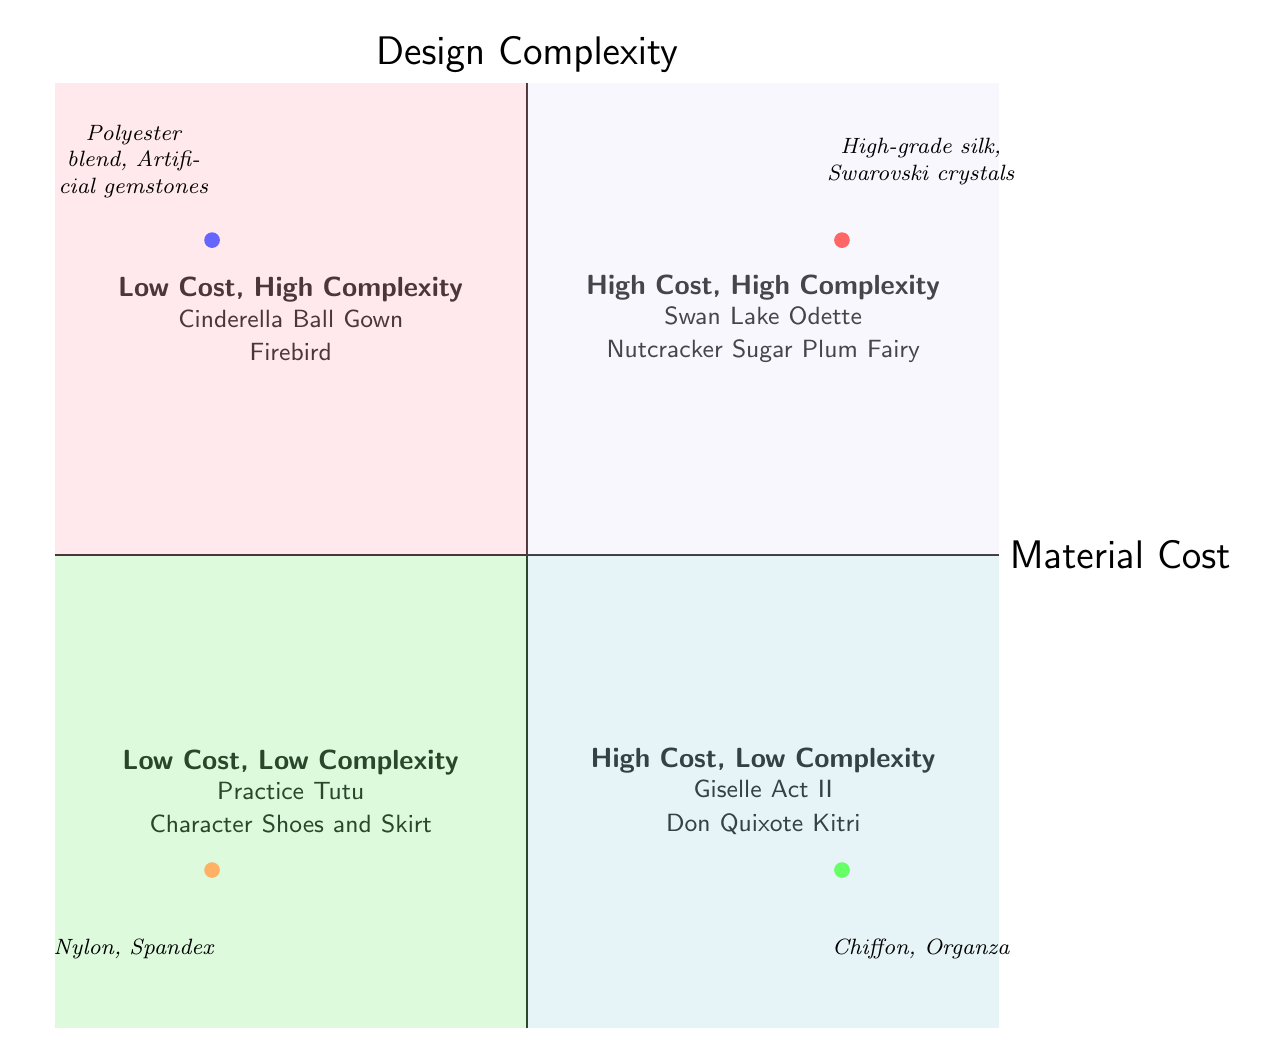What costume types are in the High Material Cost, High Design Complexity quadrant? The quadrant label "High Cost, High Complexity" lists "Swan Lake Odette" and "Nutcracker Sugar Plum Fairy" as the costume types.
Answer: Swan Lake Odette, Nutcracker Sugar Plum Fairy Which costume type contains chiffon as a material? In the "High Cost, Low Complexity" quadrant, the costume type "Giselle Act II" is identified as containing chiffon materials.
Answer: Giselle Act II How many costume types are listed in the Low Material Cost, Low Design Complexity quadrant? The "Low Cost, Low Complexity" quadrant contains two costume types: "Practice Tutu" and "Character Shoes and Skirt," totaling two costume types.
Answer: 2 What is the primary design feature of the "Nutcracker Sugar Plum Fairy"? The design features for "Nutcracker Sugar Plum Fairy" include "Intricate lace patterns" which is the primary one highlighted in the quadrant.
Answer: Intricate lace patterns Which quadrant features costumes made from polyester blend? The "Low Cost, High Complexity" quadrant contains the "Cinderella Ball Gown," which is made from a polyester blend, indicating it is in that quadrant.
Answer: Low Cost, High Complexity What is common among the costumes in the High Material Cost, Low Design Complexity quadrant? All the costumes in this quadrant use high-quality materials such as chiffon and satin, which are indicative of their high material cost.
Answer: High-quality materials What type of materials is used for the character shoes in the Low Cost, Low Complexity quadrant? The materials for "Character Shoes and Skirt" include "Leatherette," identifying the material characteristic for this costume type in the appropriate quadrant.
Answer: Leatherette Which two costume types are listed in the Low Material Cost, High Design Complexity quadrant? The "Low Cost, High Complexity" quadrant shows "Cinderella Ball Gown" and "Firebird" as the costume types in that section of the diagram.
Answer: Cinderella Ball Gown, Firebird 